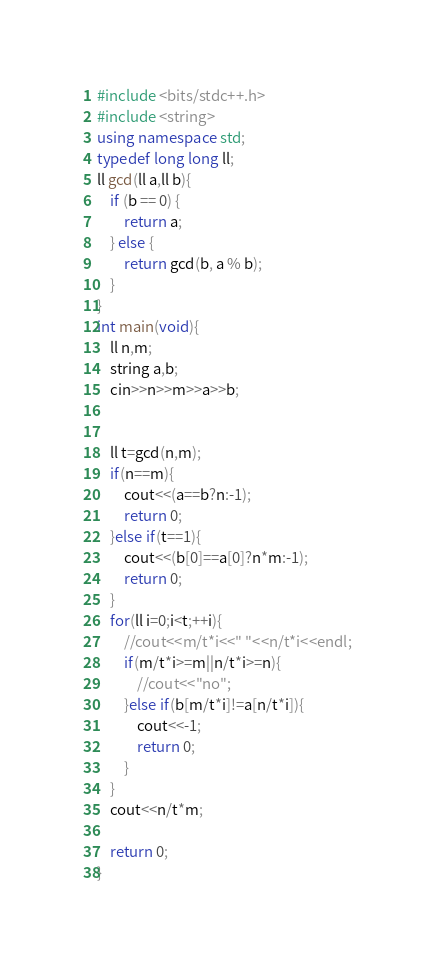<code> <loc_0><loc_0><loc_500><loc_500><_C++_>#include <bits/stdc++.h>
#include <string>
using namespace std;
typedef long long ll;
ll gcd(ll a,ll b){
    if (b == 0) {
        return a;
    } else {
        return gcd(b, a % b);
    }
}
int main(void){
    ll n,m;
    string a,b;
    cin>>n>>m>>a>>b;
    
    
    ll t=gcd(n,m);
    if(n==m){
        cout<<(a==b?n:-1);
        return 0;
    }else if(t==1){
        cout<<(b[0]==a[0]?n*m:-1);
        return 0;
    }
    for(ll i=0;i<t;++i){
        //cout<<m/t*i<<" "<<n/t*i<<endl;
        if(m/t*i>=m||n/t*i>=n){
            //cout<<"no";
        }else if(b[m/t*i]!=a[n/t*i]){
            cout<<-1;
            return 0;
        }
    }
    cout<<n/t*m;
    
    return 0;
}
</code> 